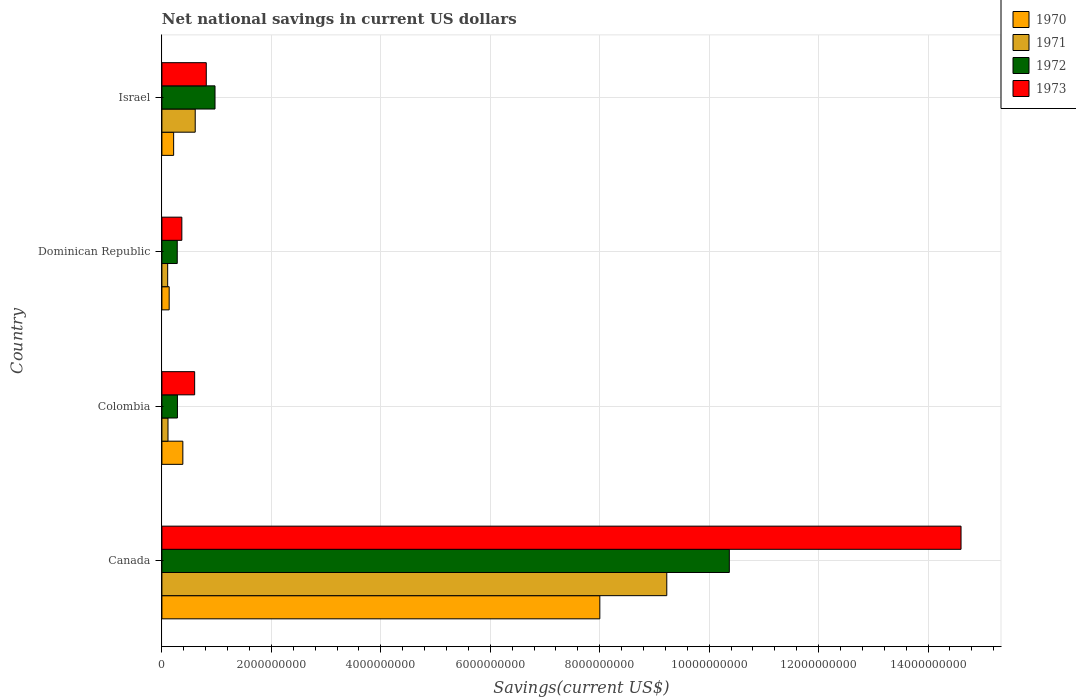How many groups of bars are there?
Keep it short and to the point. 4. Are the number of bars per tick equal to the number of legend labels?
Ensure brevity in your answer.  Yes. How many bars are there on the 1st tick from the top?
Make the answer very short. 4. How many bars are there on the 4th tick from the bottom?
Offer a terse response. 4. In how many cases, is the number of bars for a given country not equal to the number of legend labels?
Provide a short and direct response. 0. What is the net national savings in 1970 in Colombia?
Offer a very short reply. 3.83e+08. Across all countries, what is the maximum net national savings in 1971?
Your response must be concise. 9.23e+09. Across all countries, what is the minimum net national savings in 1973?
Your answer should be compact. 3.65e+08. In which country was the net national savings in 1973 minimum?
Give a very brief answer. Dominican Republic. What is the total net national savings in 1971 in the graph?
Your response must be concise. 1.01e+1. What is the difference between the net national savings in 1970 in Canada and that in Dominican Republic?
Give a very brief answer. 7.87e+09. What is the difference between the net national savings in 1972 in Dominican Republic and the net national savings in 1970 in Israel?
Make the answer very short. 6.59e+07. What is the average net national savings in 1972 per country?
Your answer should be compact. 2.98e+09. What is the difference between the net national savings in 1972 and net national savings in 1973 in Colombia?
Offer a very short reply. -3.14e+08. In how many countries, is the net national savings in 1971 greater than 4800000000 US$?
Provide a short and direct response. 1. What is the ratio of the net national savings in 1972 in Colombia to that in Israel?
Your answer should be very brief. 0.29. Is the net national savings in 1970 in Canada less than that in Colombia?
Make the answer very short. No. What is the difference between the highest and the second highest net national savings in 1971?
Keep it short and to the point. 8.62e+09. What is the difference between the highest and the lowest net national savings in 1972?
Your answer should be compact. 1.01e+1. In how many countries, is the net national savings in 1971 greater than the average net national savings in 1971 taken over all countries?
Offer a very short reply. 1. Is the sum of the net national savings in 1972 in Colombia and Dominican Republic greater than the maximum net national savings in 1970 across all countries?
Provide a succinct answer. No. Is it the case that in every country, the sum of the net national savings in 1972 and net national savings in 1971 is greater than the sum of net national savings in 1973 and net national savings in 1970?
Provide a short and direct response. No. What does the 3rd bar from the top in Israel represents?
Offer a terse response. 1971. What does the 3rd bar from the bottom in Canada represents?
Give a very brief answer. 1972. Is it the case that in every country, the sum of the net national savings in 1972 and net national savings in 1970 is greater than the net national savings in 1971?
Ensure brevity in your answer.  Yes. Are all the bars in the graph horizontal?
Give a very brief answer. Yes. How many countries are there in the graph?
Give a very brief answer. 4. Are the values on the major ticks of X-axis written in scientific E-notation?
Offer a very short reply. No. How many legend labels are there?
Your answer should be compact. 4. What is the title of the graph?
Provide a short and direct response. Net national savings in current US dollars. Does "2006" appear as one of the legend labels in the graph?
Ensure brevity in your answer.  No. What is the label or title of the X-axis?
Offer a terse response. Savings(current US$). What is the label or title of the Y-axis?
Ensure brevity in your answer.  Country. What is the Savings(current US$) of 1970 in Canada?
Provide a succinct answer. 8.00e+09. What is the Savings(current US$) in 1971 in Canada?
Offer a very short reply. 9.23e+09. What is the Savings(current US$) of 1972 in Canada?
Provide a succinct answer. 1.04e+1. What is the Savings(current US$) in 1973 in Canada?
Make the answer very short. 1.46e+1. What is the Savings(current US$) in 1970 in Colombia?
Ensure brevity in your answer.  3.83e+08. What is the Savings(current US$) in 1971 in Colombia?
Your answer should be compact. 1.11e+08. What is the Savings(current US$) in 1972 in Colombia?
Offer a very short reply. 2.84e+08. What is the Savings(current US$) of 1973 in Colombia?
Provide a short and direct response. 5.98e+08. What is the Savings(current US$) in 1970 in Dominican Republic?
Provide a short and direct response. 1.33e+08. What is the Savings(current US$) in 1971 in Dominican Republic?
Offer a very short reply. 1.05e+08. What is the Savings(current US$) of 1972 in Dominican Republic?
Give a very brief answer. 2.80e+08. What is the Savings(current US$) in 1973 in Dominican Republic?
Offer a very short reply. 3.65e+08. What is the Savings(current US$) of 1970 in Israel?
Provide a succinct answer. 2.15e+08. What is the Savings(current US$) of 1971 in Israel?
Your answer should be compact. 6.09e+08. What is the Savings(current US$) in 1972 in Israel?
Make the answer very short. 9.71e+08. What is the Savings(current US$) of 1973 in Israel?
Your answer should be very brief. 8.11e+08. Across all countries, what is the maximum Savings(current US$) of 1970?
Your response must be concise. 8.00e+09. Across all countries, what is the maximum Savings(current US$) in 1971?
Your answer should be compact. 9.23e+09. Across all countries, what is the maximum Savings(current US$) of 1972?
Keep it short and to the point. 1.04e+1. Across all countries, what is the maximum Savings(current US$) in 1973?
Offer a very short reply. 1.46e+1. Across all countries, what is the minimum Savings(current US$) in 1970?
Provide a short and direct response. 1.33e+08. Across all countries, what is the minimum Savings(current US$) in 1971?
Provide a succinct answer. 1.05e+08. Across all countries, what is the minimum Savings(current US$) in 1972?
Your response must be concise. 2.80e+08. Across all countries, what is the minimum Savings(current US$) of 1973?
Provide a succinct answer. 3.65e+08. What is the total Savings(current US$) of 1970 in the graph?
Ensure brevity in your answer.  8.73e+09. What is the total Savings(current US$) of 1971 in the graph?
Keep it short and to the point. 1.01e+1. What is the total Savings(current US$) of 1972 in the graph?
Offer a terse response. 1.19e+1. What is the total Savings(current US$) of 1973 in the graph?
Your answer should be very brief. 1.64e+1. What is the difference between the Savings(current US$) in 1970 in Canada and that in Colombia?
Keep it short and to the point. 7.62e+09. What is the difference between the Savings(current US$) of 1971 in Canada and that in Colombia?
Keep it short and to the point. 9.11e+09. What is the difference between the Savings(current US$) in 1972 in Canada and that in Colombia?
Offer a very short reply. 1.01e+1. What is the difference between the Savings(current US$) of 1973 in Canada and that in Colombia?
Offer a terse response. 1.40e+1. What is the difference between the Savings(current US$) of 1970 in Canada and that in Dominican Republic?
Your answer should be compact. 7.87e+09. What is the difference between the Savings(current US$) in 1971 in Canada and that in Dominican Republic?
Ensure brevity in your answer.  9.12e+09. What is the difference between the Savings(current US$) of 1972 in Canada and that in Dominican Republic?
Ensure brevity in your answer.  1.01e+1. What is the difference between the Savings(current US$) in 1973 in Canada and that in Dominican Republic?
Your answer should be compact. 1.42e+1. What is the difference between the Savings(current US$) of 1970 in Canada and that in Israel?
Give a very brief answer. 7.79e+09. What is the difference between the Savings(current US$) of 1971 in Canada and that in Israel?
Offer a terse response. 8.62e+09. What is the difference between the Savings(current US$) of 1972 in Canada and that in Israel?
Give a very brief answer. 9.40e+09. What is the difference between the Savings(current US$) in 1973 in Canada and that in Israel?
Make the answer very short. 1.38e+1. What is the difference between the Savings(current US$) of 1970 in Colombia and that in Dominican Republic?
Give a very brief answer. 2.50e+08. What is the difference between the Savings(current US$) of 1971 in Colombia and that in Dominican Republic?
Offer a very short reply. 6.03e+06. What is the difference between the Savings(current US$) in 1972 in Colombia and that in Dominican Republic?
Keep it short and to the point. 3.48e+06. What is the difference between the Savings(current US$) of 1973 in Colombia and that in Dominican Republic?
Your answer should be very brief. 2.34e+08. What is the difference between the Savings(current US$) of 1970 in Colombia and that in Israel?
Offer a terse response. 1.68e+08. What is the difference between the Savings(current US$) of 1971 in Colombia and that in Israel?
Ensure brevity in your answer.  -4.97e+08. What is the difference between the Savings(current US$) of 1972 in Colombia and that in Israel?
Ensure brevity in your answer.  -6.87e+08. What is the difference between the Savings(current US$) in 1973 in Colombia and that in Israel?
Provide a succinct answer. -2.12e+08. What is the difference between the Savings(current US$) of 1970 in Dominican Republic and that in Israel?
Make the answer very short. -8.19e+07. What is the difference between the Savings(current US$) in 1971 in Dominican Republic and that in Israel?
Your response must be concise. -5.03e+08. What is the difference between the Savings(current US$) of 1972 in Dominican Republic and that in Israel?
Offer a terse response. -6.90e+08. What is the difference between the Savings(current US$) in 1973 in Dominican Republic and that in Israel?
Your response must be concise. -4.46e+08. What is the difference between the Savings(current US$) of 1970 in Canada and the Savings(current US$) of 1971 in Colombia?
Make the answer very short. 7.89e+09. What is the difference between the Savings(current US$) in 1970 in Canada and the Savings(current US$) in 1972 in Colombia?
Offer a terse response. 7.72e+09. What is the difference between the Savings(current US$) of 1970 in Canada and the Savings(current US$) of 1973 in Colombia?
Your answer should be compact. 7.40e+09. What is the difference between the Savings(current US$) in 1971 in Canada and the Savings(current US$) in 1972 in Colombia?
Your answer should be very brief. 8.94e+09. What is the difference between the Savings(current US$) of 1971 in Canada and the Savings(current US$) of 1973 in Colombia?
Your answer should be very brief. 8.63e+09. What is the difference between the Savings(current US$) in 1972 in Canada and the Savings(current US$) in 1973 in Colombia?
Your response must be concise. 9.77e+09. What is the difference between the Savings(current US$) in 1970 in Canada and the Savings(current US$) in 1971 in Dominican Republic?
Give a very brief answer. 7.90e+09. What is the difference between the Savings(current US$) of 1970 in Canada and the Savings(current US$) of 1972 in Dominican Republic?
Give a very brief answer. 7.72e+09. What is the difference between the Savings(current US$) in 1970 in Canada and the Savings(current US$) in 1973 in Dominican Republic?
Offer a terse response. 7.64e+09. What is the difference between the Savings(current US$) in 1971 in Canada and the Savings(current US$) in 1972 in Dominican Republic?
Offer a terse response. 8.94e+09. What is the difference between the Savings(current US$) of 1971 in Canada and the Savings(current US$) of 1973 in Dominican Republic?
Offer a very short reply. 8.86e+09. What is the difference between the Savings(current US$) of 1972 in Canada and the Savings(current US$) of 1973 in Dominican Republic?
Offer a very short reply. 1.00e+1. What is the difference between the Savings(current US$) in 1970 in Canada and the Savings(current US$) in 1971 in Israel?
Provide a succinct answer. 7.39e+09. What is the difference between the Savings(current US$) in 1970 in Canada and the Savings(current US$) in 1972 in Israel?
Make the answer very short. 7.03e+09. What is the difference between the Savings(current US$) of 1970 in Canada and the Savings(current US$) of 1973 in Israel?
Your answer should be compact. 7.19e+09. What is the difference between the Savings(current US$) of 1971 in Canada and the Savings(current US$) of 1972 in Israel?
Ensure brevity in your answer.  8.25e+09. What is the difference between the Savings(current US$) of 1971 in Canada and the Savings(current US$) of 1973 in Israel?
Ensure brevity in your answer.  8.41e+09. What is the difference between the Savings(current US$) of 1972 in Canada and the Savings(current US$) of 1973 in Israel?
Your response must be concise. 9.56e+09. What is the difference between the Savings(current US$) in 1970 in Colombia and the Savings(current US$) in 1971 in Dominican Republic?
Make the answer very short. 2.77e+08. What is the difference between the Savings(current US$) in 1970 in Colombia and the Savings(current US$) in 1972 in Dominican Republic?
Ensure brevity in your answer.  1.02e+08. What is the difference between the Savings(current US$) of 1970 in Colombia and the Savings(current US$) of 1973 in Dominican Republic?
Provide a short and direct response. 1.82e+07. What is the difference between the Savings(current US$) in 1971 in Colombia and the Savings(current US$) in 1972 in Dominican Republic?
Offer a very short reply. -1.69e+08. What is the difference between the Savings(current US$) in 1971 in Colombia and the Savings(current US$) in 1973 in Dominican Republic?
Provide a short and direct response. -2.53e+08. What is the difference between the Savings(current US$) of 1972 in Colombia and the Savings(current US$) of 1973 in Dominican Republic?
Keep it short and to the point. -8.05e+07. What is the difference between the Savings(current US$) of 1970 in Colombia and the Savings(current US$) of 1971 in Israel?
Provide a succinct answer. -2.26e+08. What is the difference between the Savings(current US$) in 1970 in Colombia and the Savings(current US$) in 1972 in Israel?
Your response must be concise. -5.88e+08. What is the difference between the Savings(current US$) in 1970 in Colombia and the Savings(current US$) in 1973 in Israel?
Make the answer very short. -4.28e+08. What is the difference between the Savings(current US$) of 1971 in Colombia and the Savings(current US$) of 1972 in Israel?
Provide a succinct answer. -8.59e+08. What is the difference between the Savings(current US$) in 1971 in Colombia and the Savings(current US$) in 1973 in Israel?
Your answer should be compact. -6.99e+08. What is the difference between the Savings(current US$) in 1972 in Colombia and the Savings(current US$) in 1973 in Israel?
Provide a succinct answer. -5.27e+08. What is the difference between the Savings(current US$) of 1970 in Dominican Republic and the Savings(current US$) of 1971 in Israel?
Provide a short and direct response. -4.76e+08. What is the difference between the Savings(current US$) in 1970 in Dominican Republic and the Savings(current US$) in 1972 in Israel?
Your answer should be very brief. -8.38e+08. What is the difference between the Savings(current US$) in 1970 in Dominican Republic and the Savings(current US$) in 1973 in Israel?
Make the answer very short. -6.78e+08. What is the difference between the Savings(current US$) of 1971 in Dominican Republic and the Savings(current US$) of 1972 in Israel?
Provide a short and direct response. -8.65e+08. What is the difference between the Savings(current US$) of 1971 in Dominican Republic and the Savings(current US$) of 1973 in Israel?
Provide a short and direct response. -7.05e+08. What is the difference between the Savings(current US$) of 1972 in Dominican Republic and the Savings(current US$) of 1973 in Israel?
Your response must be concise. -5.30e+08. What is the average Savings(current US$) of 1970 per country?
Provide a short and direct response. 2.18e+09. What is the average Savings(current US$) in 1971 per country?
Your answer should be very brief. 2.51e+09. What is the average Savings(current US$) of 1972 per country?
Keep it short and to the point. 2.98e+09. What is the average Savings(current US$) in 1973 per country?
Provide a short and direct response. 4.09e+09. What is the difference between the Savings(current US$) in 1970 and Savings(current US$) in 1971 in Canada?
Provide a short and direct response. -1.22e+09. What is the difference between the Savings(current US$) in 1970 and Savings(current US$) in 1972 in Canada?
Offer a terse response. -2.37e+09. What is the difference between the Savings(current US$) of 1970 and Savings(current US$) of 1973 in Canada?
Make the answer very short. -6.60e+09. What is the difference between the Savings(current US$) of 1971 and Savings(current US$) of 1972 in Canada?
Provide a succinct answer. -1.14e+09. What is the difference between the Savings(current US$) of 1971 and Savings(current US$) of 1973 in Canada?
Make the answer very short. -5.38e+09. What is the difference between the Savings(current US$) in 1972 and Savings(current US$) in 1973 in Canada?
Your response must be concise. -4.23e+09. What is the difference between the Savings(current US$) in 1970 and Savings(current US$) in 1971 in Colombia?
Give a very brief answer. 2.71e+08. What is the difference between the Savings(current US$) of 1970 and Savings(current US$) of 1972 in Colombia?
Make the answer very short. 9.87e+07. What is the difference between the Savings(current US$) in 1970 and Savings(current US$) in 1973 in Colombia?
Give a very brief answer. -2.16e+08. What is the difference between the Savings(current US$) of 1971 and Savings(current US$) of 1972 in Colombia?
Your answer should be compact. -1.73e+08. What is the difference between the Savings(current US$) in 1971 and Savings(current US$) in 1973 in Colombia?
Offer a very short reply. -4.87e+08. What is the difference between the Savings(current US$) in 1972 and Savings(current US$) in 1973 in Colombia?
Your answer should be compact. -3.14e+08. What is the difference between the Savings(current US$) of 1970 and Savings(current US$) of 1971 in Dominican Republic?
Keep it short and to the point. 2.74e+07. What is the difference between the Savings(current US$) of 1970 and Savings(current US$) of 1972 in Dominican Republic?
Your answer should be very brief. -1.48e+08. What is the difference between the Savings(current US$) in 1970 and Savings(current US$) in 1973 in Dominican Republic?
Your answer should be very brief. -2.32e+08. What is the difference between the Savings(current US$) of 1971 and Savings(current US$) of 1972 in Dominican Republic?
Offer a very short reply. -1.75e+08. What is the difference between the Savings(current US$) in 1971 and Savings(current US$) in 1973 in Dominican Republic?
Provide a short and direct response. -2.59e+08. What is the difference between the Savings(current US$) in 1972 and Savings(current US$) in 1973 in Dominican Republic?
Provide a succinct answer. -8.40e+07. What is the difference between the Savings(current US$) in 1970 and Savings(current US$) in 1971 in Israel?
Give a very brief answer. -3.94e+08. What is the difference between the Savings(current US$) of 1970 and Savings(current US$) of 1972 in Israel?
Your answer should be compact. -7.56e+08. What is the difference between the Savings(current US$) of 1970 and Savings(current US$) of 1973 in Israel?
Provide a succinct answer. -5.96e+08. What is the difference between the Savings(current US$) of 1971 and Savings(current US$) of 1972 in Israel?
Provide a short and direct response. -3.62e+08. What is the difference between the Savings(current US$) in 1971 and Savings(current US$) in 1973 in Israel?
Offer a very short reply. -2.02e+08. What is the difference between the Savings(current US$) of 1972 and Savings(current US$) of 1973 in Israel?
Ensure brevity in your answer.  1.60e+08. What is the ratio of the Savings(current US$) of 1970 in Canada to that in Colombia?
Ensure brevity in your answer.  20.91. What is the ratio of the Savings(current US$) in 1971 in Canada to that in Colombia?
Give a very brief answer. 82.79. What is the ratio of the Savings(current US$) in 1972 in Canada to that in Colombia?
Ensure brevity in your answer.  36.51. What is the ratio of the Savings(current US$) of 1973 in Canada to that in Colombia?
Your answer should be compact. 24.4. What is the ratio of the Savings(current US$) of 1970 in Canada to that in Dominican Republic?
Offer a very short reply. 60.27. What is the ratio of the Savings(current US$) in 1971 in Canada to that in Dominican Republic?
Offer a terse response. 87.52. What is the ratio of the Savings(current US$) in 1972 in Canada to that in Dominican Republic?
Offer a very short reply. 36.96. What is the ratio of the Savings(current US$) in 1973 in Canada to that in Dominican Republic?
Provide a succinct answer. 40.06. What is the ratio of the Savings(current US$) in 1970 in Canada to that in Israel?
Your answer should be very brief. 37.28. What is the ratio of the Savings(current US$) in 1971 in Canada to that in Israel?
Your response must be concise. 15.16. What is the ratio of the Savings(current US$) of 1972 in Canada to that in Israel?
Ensure brevity in your answer.  10.68. What is the ratio of the Savings(current US$) in 1973 in Canada to that in Israel?
Give a very brief answer. 18.01. What is the ratio of the Savings(current US$) in 1970 in Colombia to that in Dominican Republic?
Offer a terse response. 2.88. What is the ratio of the Savings(current US$) of 1971 in Colombia to that in Dominican Republic?
Your answer should be compact. 1.06. What is the ratio of the Savings(current US$) of 1972 in Colombia to that in Dominican Republic?
Your answer should be very brief. 1.01. What is the ratio of the Savings(current US$) in 1973 in Colombia to that in Dominican Republic?
Offer a very short reply. 1.64. What is the ratio of the Savings(current US$) in 1970 in Colombia to that in Israel?
Offer a very short reply. 1.78. What is the ratio of the Savings(current US$) in 1971 in Colombia to that in Israel?
Offer a very short reply. 0.18. What is the ratio of the Savings(current US$) in 1972 in Colombia to that in Israel?
Your response must be concise. 0.29. What is the ratio of the Savings(current US$) of 1973 in Colombia to that in Israel?
Make the answer very short. 0.74. What is the ratio of the Savings(current US$) of 1970 in Dominican Republic to that in Israel?
Your answer should be very brief. 0.62. What is the ratio of the Savings(current US$) in 1971 in Dominican Republic to that in Israel?
Your response must be concise. 0.17. What is the ratio of the Savings(current US$) of 1972 in Dominican Republic to that in Israel?
Offer a very short reply. 0.29. What is the ratio of the Savings(current US$) of 1973 in Dominican Republic to that in Israel?
Provide a short and direct response. 0.45. What is the difference between the highest and the second highest Savings(current US$) of 1970?
Offer a terse response. 7.62e+09. What is the difference between the highest and the second highest Savings(current US$) in 1971?
Make the answer very short. 8.62e+09. What is the difference between the highest and the second highest Savings(current US$) in 1972?
Offer a terse response. 9.40e+09. What is the difference between the highest and the second highest Savings(current US$) of 1973?
Your answer should be compact. 1.38e+1. What is the difference between the highest and the lowest Savings(current US$) of 1970?
Ensure brevity in your answer.  7.87e+09. What is the difference between the highest and the lowest Savings(current US$) in 1971?
Provide a succinct answer. 9.12e+09. What is the difference between the highest and the lowest Savings(current US$) in 1972?
Make the answer very short. 1.01e+1. What is the difference between the highest and the lowest Savings(current US$) of 1973?
Your answer should be very brief. 1.42e+1. 